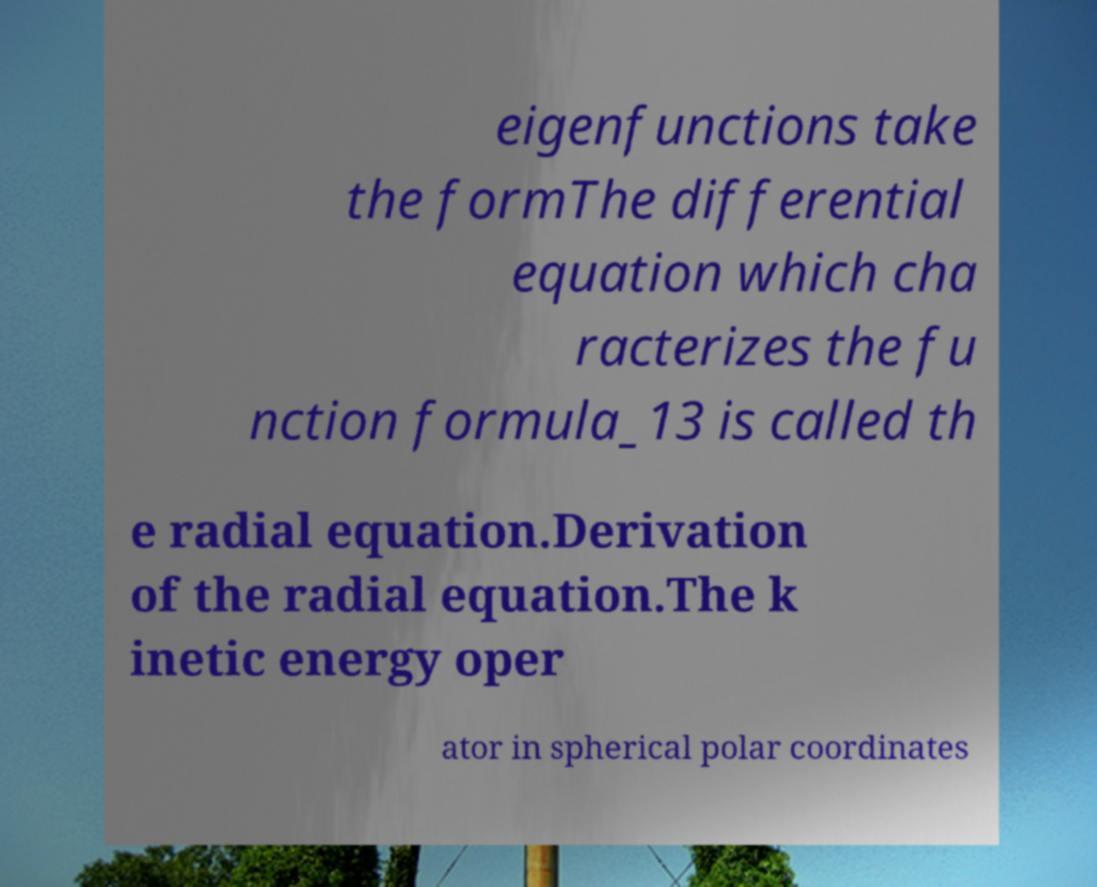Please identify and transcribe the text found in this image. eigenfunctions take the formThe differential equation which cha racterizes the fu nction formula_13 is called th e radial equation.Derivation of the radial equation.The k inetic energy oper ator in spherical polar coordinates 